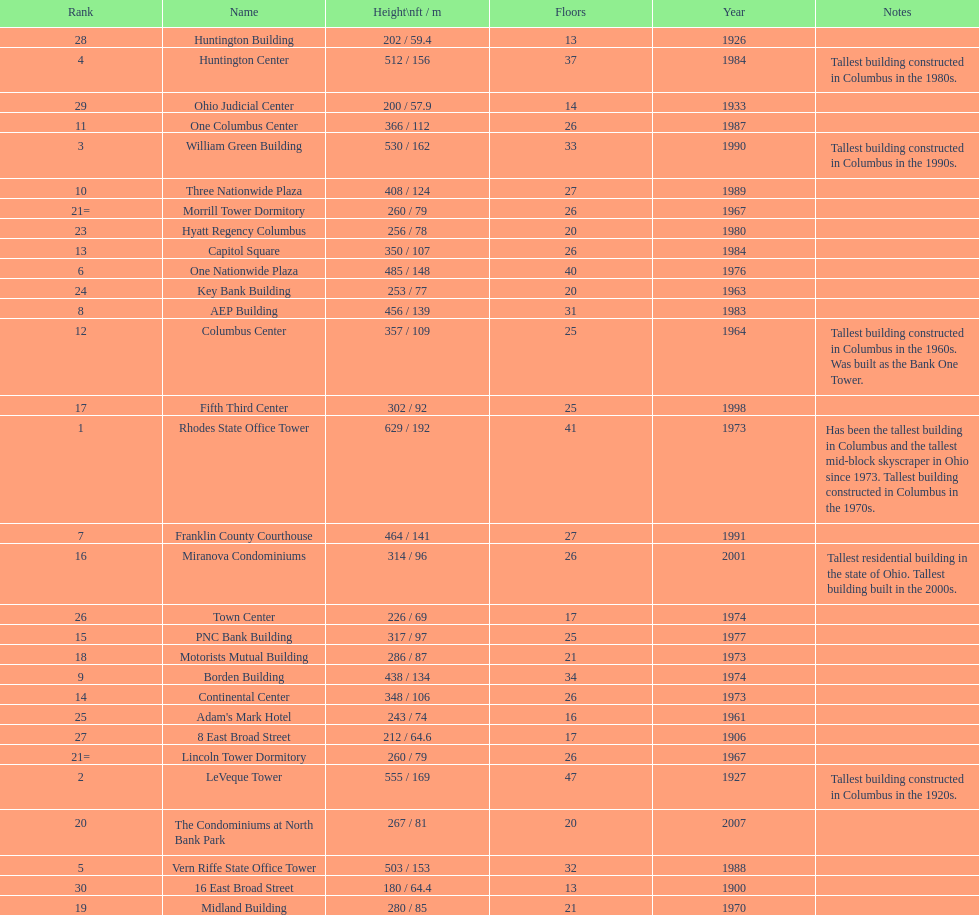Which is the tallest building? Rhodes State Office Tower. 